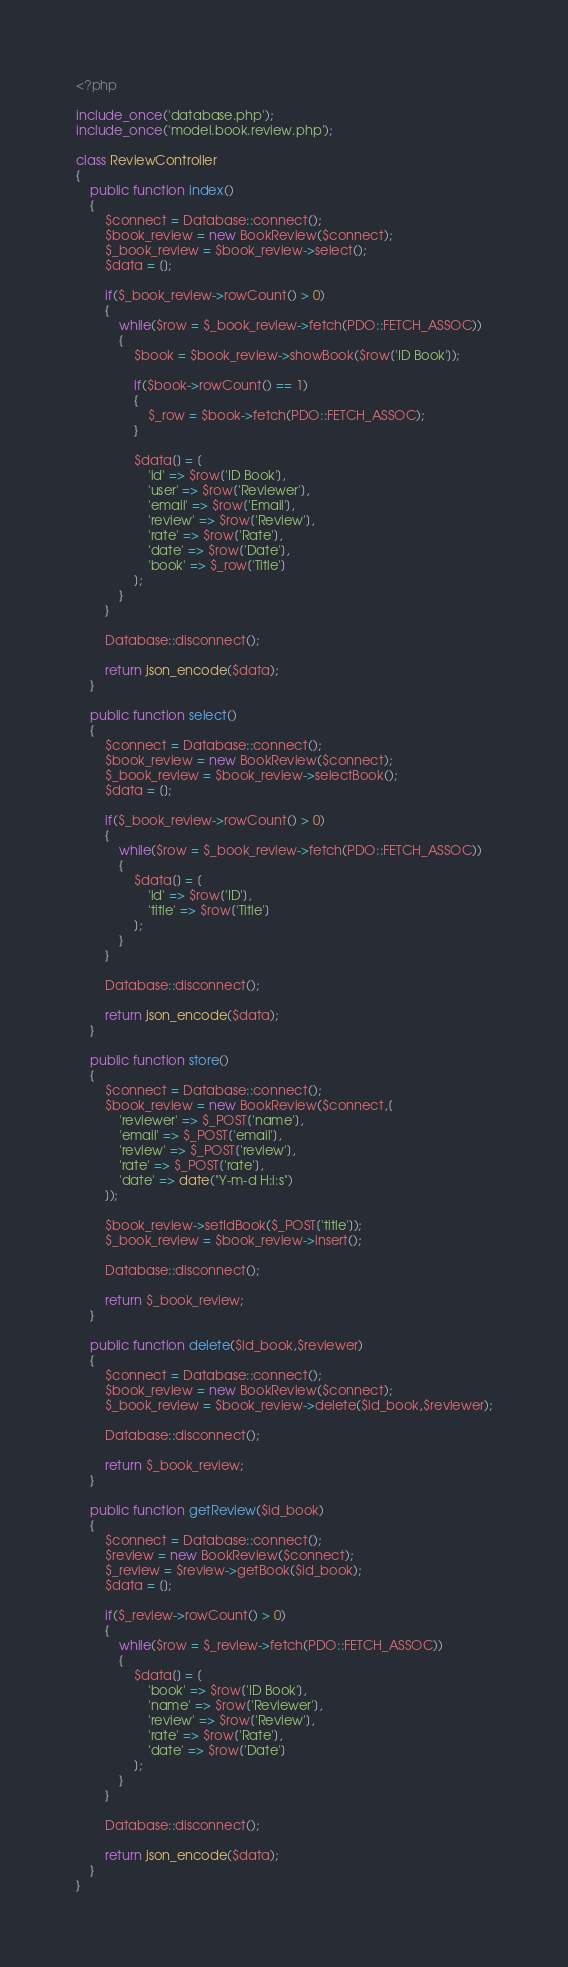Convert code to text. <code><loc_0><loc_0><loc_500><loc_500><_PHP_><?php

include_once('database.php');
include_once('model.book.review.php');

class ReviewController
{
	public function index()
	{
		$connect = Database::connect();
		$book_review = new BookReview($connect);
		$_book_review = $book_review->select();
		$data = [];

		if($_book_review->rowCount() > 0)
		{
			while($row = $_book_review->fetch(PDO::FETCH_ASSOC))
			{
				$book = $book_review->showBook($row['ID Book']);

				if($book->rowCount() == 1)
				{
					$_row = $book->fetch(PDO::FETCH_ASSOC);
				}

				$data[] = [
					'id' => $row['ID Book'],
					'user' => $row['Reviewer'],
					'email' => $row['Email'],
					'review' => $row['Review'],
					'rate' => $row['Rate'],
					'date' => $row['Date'],
					'book' => $_row['Title']
				];
			}
		}

		Database::disconnect();

		return json_encode($data);
	}

	public function select()
	{
		$connect = Database::connect();
		$book_review = new BookReview($connect);
		$_book_review = $book_review->selectBook();
		$data = [];

		if($_book_review->rowCount() > 0)
		{
			while($row = $_book_review->fetch(PDO::FETCH_ASSOC))
			{
				$data[] = [
					'id' => $row['ID'],
					'title' => $row['Title']
				];
			}
		}

		Database::disconnect();

		return json_encode($data);
	}

	public function store()
	{
		$connect = Database::connect();
		$book_review = new BookReview($connect,[
			'reviewer' => $_POST['name'],
			'email' => $_POST['email'],
			'review' => $_POST['review'],
			'rate' => $_POST['rate'],
			'date' => date("Y-m-d H:i:s")
		]);

		$book_review->setIdBook($_POST['title']);
		$_book_review = $book_review->insert();

		Database::disconnect();

		return $_book_review;
	}

	public function delete($id_book,$reviewer)
	{
		$connect = Database::connect();
		$book_review = new BookReview($connect);
		$_book_review = $book_review->delete($id_book,$reviewer);

		Database::disconnect();

		return $_book_review;
	}

	public function getReview($id_book)
	{
		$connect = Database::connect();
		$review = new BookReview($connect);
		$_review = $review->getBook($id_book);
		$data = [];

		if($_review->rowCount() > 0)
		{
			while($row = $_review->fetch(PDO::FETCH_ASSOC))
			{
				$data[] = [
					'book' => $row['ID Book'],
					'name' => $row['Reviewer'],
					'review' => $row['Review'],
					'rate' => $row['Rate'],
					'date' => $row['Date']
				];
			}
		}

		Database::disconnect();

		return json_encode($data);
	}
}
</code> 